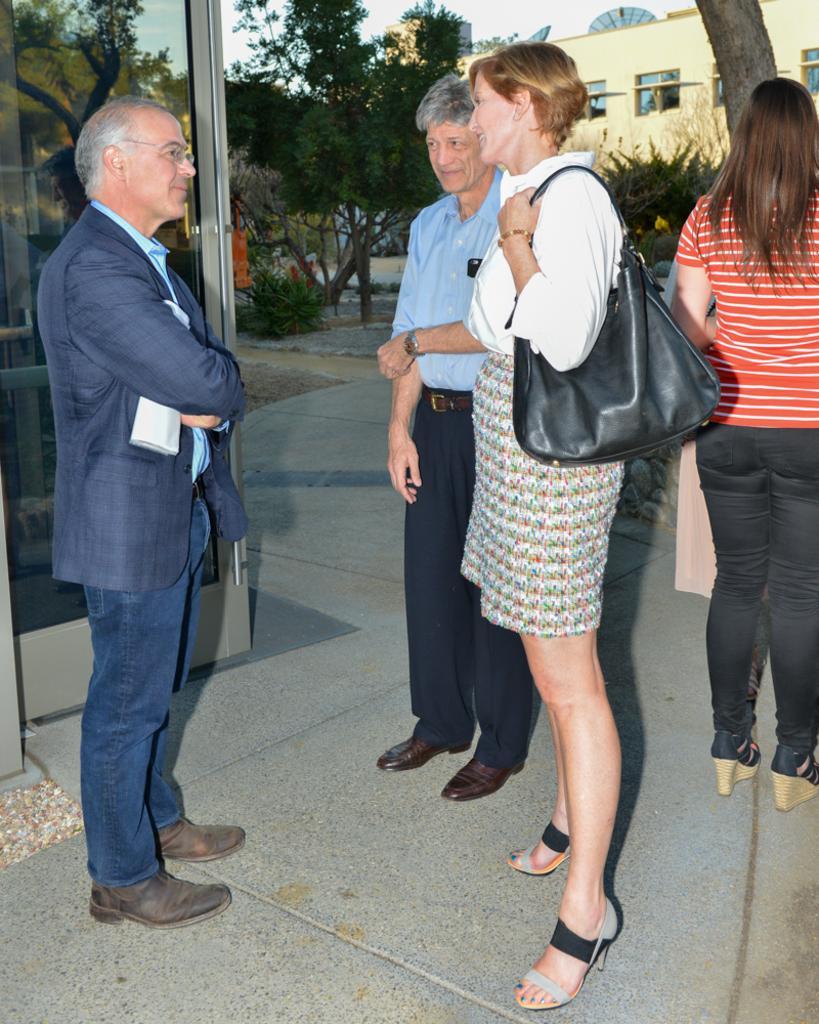Please provide a concise description of this image. In this picture there are four people standing in the foreground. At the back there is a building and there are trees. On the left side of the image there is a door and there is reflection of tree and sky on the mirror. At the top there is sky. At the bottom there is a floor and there are antennas on the top of the building. 